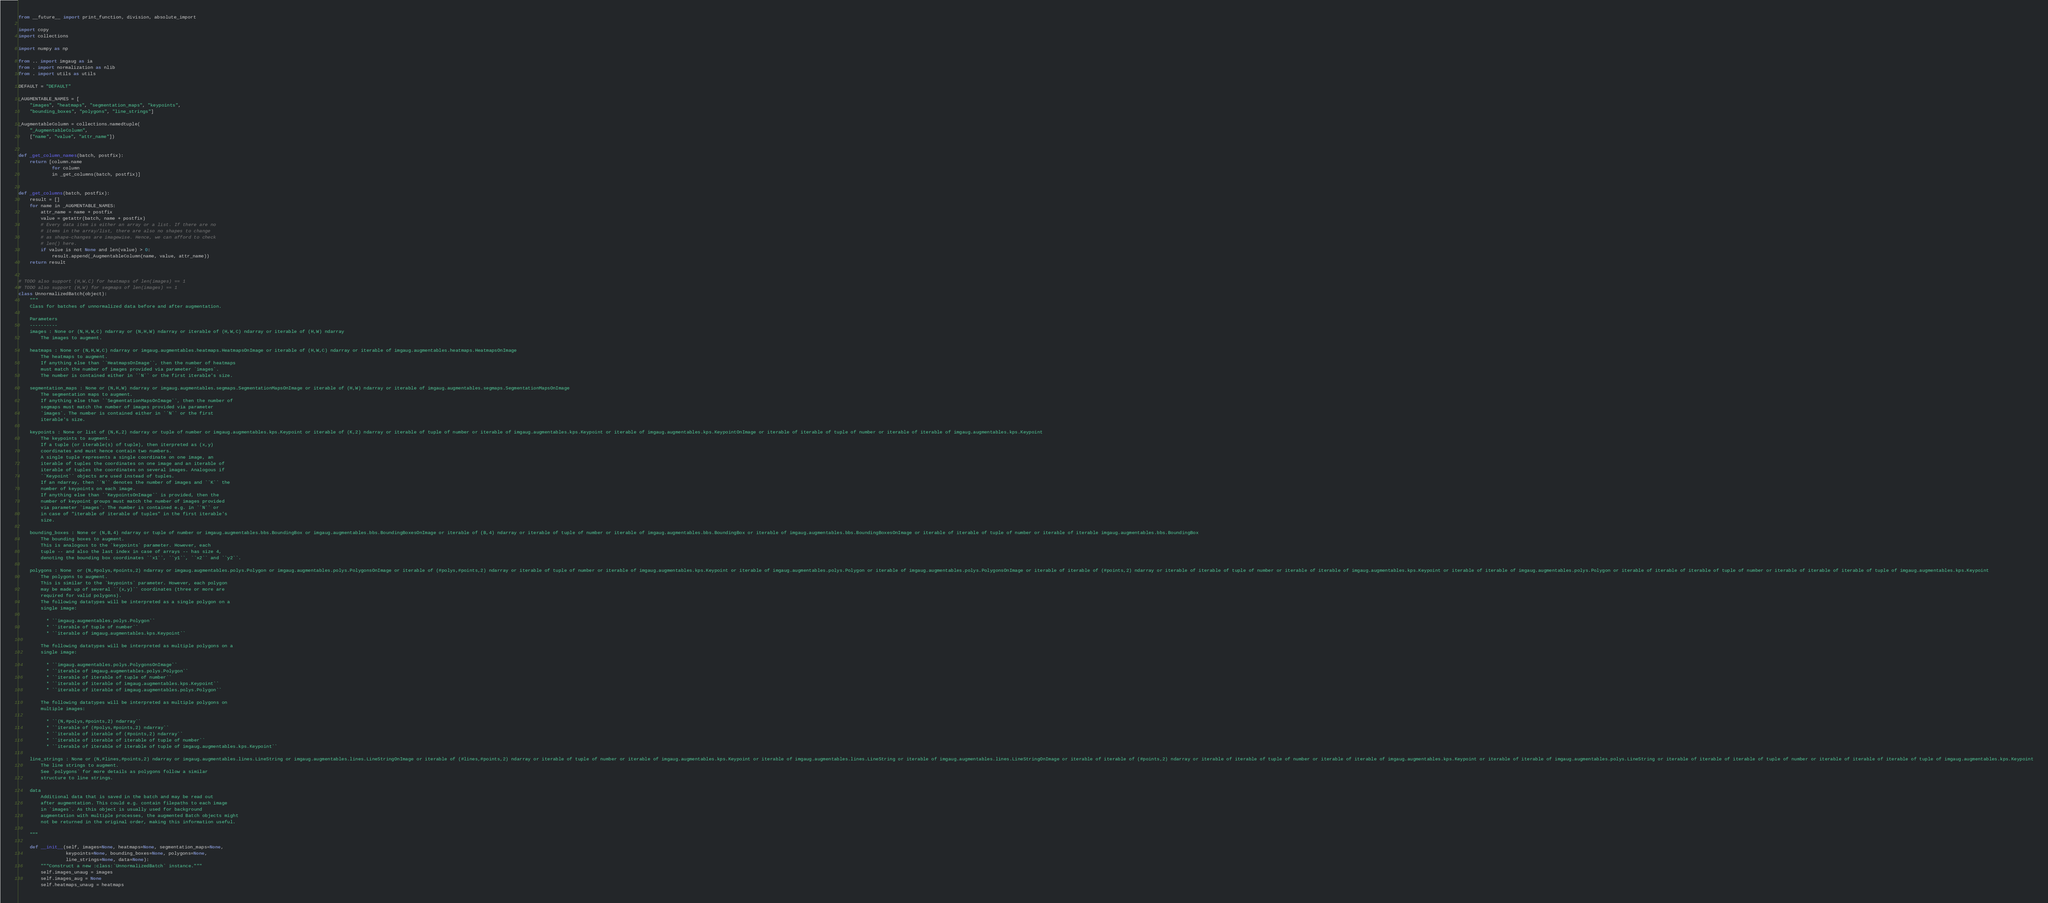Convert code to text. <code><loc_0><loc_0><loc_500><loc_500><_Python_>from __future__ import print_function, division, absolute_import

import copy
import collections

import numpy as np

from .. import imgaug as ia
from . import normalization as nlib
from . import utils as utils

DEFAULT = "DEFAULT"

_AUGMENTABLE_NAMES = [
    "images", "heatmaps", "segmentation_maps", "keypoints",
    "bounding_boxes", "polygons", "line_strings"]

_AugmentableColumn = collections.namedtuple(
    "_AugmentableColumn",
    ["name", "value", "attr_name"])


def _get_column_names(batch, postfix):
    return [column.name
            for column
            in _get_columns(batch, postfix)]


def _get_columns(batch, postfix):
    result = []
    for name in _AUGMENTABLE_NAMES:
        attr_name = name + postfix
        value = getattr(batch, name + postfix)
        # Every data item is either an array or a list. If there are no
        # items in the array/list, there are also no shapes to change
        # as shape-changes are imagewise. Hence, we can afford to check
        # len() here.
        if value is not None and len(value) > 0:
            result.append(_AugmentableColumn(name, value, attr_name))
    return result


# TODO also support (H,W,C) for heatmaps of len(images) == 1
# TODO also support (H,W) for segmaps of len(images) == 1
class UnnormalizedBatch(object):
    """
    Class for batches of unnormalized data before and after augmentation.

    Parameters
    ----------
    images : None or (N,H,W,C) ndarray or (N,H,W) ndarray or iterable of (H,W,C) ndarray or iterable of (H,W) ndarray
        The images to augment.

    heatmaps : None or (N,H,W,C) ndarray or imgaug.augmentables.heatmaps.HeatmapsOnImage or iterable of (H,W,C) ndarray or iterable of imgaug.augmentables.heatmaps.HeatmapsOnImage
        The heatmaps to augment.
        If anything else than ``HeatmapsOnImage``, then the number of heatmaps
        must match the number of images provided via parameter `images`.
        The number is contained either in ``N`` or the first iterable's size.

    segmentation_maps : None or (N,H,W) ndarray or imgaug.augmentables.segmaps.SegmentationMapsOnImage or iterable of (H,W) ndarray or iterable of imgaug.augmentables.segmaps.SegmentationMapsOnImage
        The segmentation maps to augment.
        If anything else than ``SegmentationMapsOnImage``, then the number of
        segmaps must match the number of images provided via parameter
        `images`. The number is contained either in ``N`` or the first
        iterable's size.

    keypoints : None or list of (N,K,2) ndarray or tuple of number or imgaug.augmentables.kps.Keypoint or iterable of (K,2) ndarray or iterable of tuple of number or iterable of imgaug.augmentables.kps.Keypoint or iterable of imgaug.augmentables.kps.KeypointOnImage or iterable of iterable of tuple of number or iterable of iterable of imgaug.augmentables.kps.Keypoint
        The keypoints to augment.
        If a tuple (or iterable(s) of tuple), then iterpreted as (x,y)
        coordinates and must hence contain two numbers.
        A single tuple represents a single coordinate on one image, an
        iterable of tuples the coordinates on one image and an iterable of
        iterable of tuples the coordinates on several images. Analogous if
        ``Keypoint`` objects are used instead of tuples.
        If an ndarray, then ``N`` denotes the number of images and ``K`` the
        number of keypoints on each image.
        If anything else than ``KeypointsOnImage`` is provided, then the
        number of keypoint groups must match the number of images provided
        via parameter `images`. The number is contained e.g. in ``N`` or
        in case of "iterable of iterable of tuples" in the first iterable's
        size.

    bounding_boxes : None or (N,B,4) ndarray or tuple of number or imgaug.augmentables.bbs.BoundingBox or imgaug.augmentables.bbs.BoundingBoxesOnImage or iterable of (B,4) ndarray or iterable of tuple of number or iterable of imgaug.augmentables.bbs.BoundingBox or iterable of imgaug.augmentables.bbs.BoundingBoxesOnImage or iterable of iterable of tuple of number or iterable of iterable imgaug.augmentables.bbs.BoundingBox
        The bounding boxes to augment.
        This is analogous to the `keypoints` parameter. However, each
        tuple -- and also the last index in case of arrays -- has size 4,
        denoting the bounding box coordinates ``x1``, ``y1``, ``x2`` and ``y2``.

    polygons : None  or (N,#polys,#points,2) ndarray or imgaug.augmentables.polys.Polygon or imgaug.augmentables.polys.PolygonsOnImage or iterable of (#polys,#points,2) ndarray or iterable of tuple of number or iterable of imgaug.augmentables.kps.Keypoint or iterable of imgaug.augmentables.polys.Polygon or iterable of imgaug.augmentables.polys.PolygonsOnImage or iterable of iterable of (#points,2) ndarray or iterable of iterable of tuple of number or iterable of iterable of imgaug.augmentables.kps.Keypoint or iterable of iterable of imgaug.augmentables.polys.Polygon or iterable of iterable of iterable of tuple of number or iterable of iterable of iterable of tuple of imgaug.augmentables.kps.Keypoint
        The polygons to augment.
        This is similar to the `keypoints` parameter. However, each polygon
        may be made up of several ``(x,y)`` coordinates (three or more are
        required for valid polygons).
        The following datatypes will be interpreted as a single polygon on a
        single image:

          * ``imgaug.augmentables.polys.Polygon``
          * ``iterable of tuple of number``
          * ``iterable of imgaug.augmentables.kps.Keypoint``

        The following datatypes will be interpreted as multiple polygons on a
        single image:

          * ``imgaug.augmentables.polys.PolygonsOnImage``
          * ``iterable of imgaug.augmentables.polys.Polygon``
          * ``iterable of iterable of tuple of number``
          * ``iterable of iterable of imgaug.augmentables.kps.Keypoint``
          * ``iterable of iterable of imgaug.augmentables.polys.Polygon``

        The following datatypes will be interpreted as multiple polygons on
        multiple images:

          * ``(N,#polys,#points,2) ndarray``
          * ``iterable of (#polys,#points,2) ndarray``
          * ``iterable of iterable of (#points,2) ndarray``
          * ``iterable of iterable of iterable of tuple of number``
          * ``iterable of iterable of iterable of tuple of imgaug.augmentables.kps.Keypoint``

    line_strings : None or (N,#lines,#points,2) ndarray or imgaug.augmentables.lines.LineString or imgaug.augmentables.lines.LineStringOnImage or iterable of (#lines,#points,2) ndarray or iterable of tuple of number or iterable of imgaug.augmentables.kps.Keypoint or iterable of imgaug.augmentables.lines.LineString or iterable of imgaug.augmentables.lines.LineStringOnImage or iterable of iterable of (#points,2) ndarray or iterable of iterable of tuple of number or iterable of iterable of imgaug.augmentables.kps.Keypoint or iterable of iterable of imgaug.augmentables.polys.LineString or iterable of iterable of iterable of tuple of number or iterable of iterable of iterable of tuple of imgaug.augmentables.kps.Keypoint
        The line strings to augment.
        See `polygons` for more details as polygons follow a similar
        structure to line strings.

    data
        Additional data that is saved in the batch and may be read out
        after augmentation. This could e.g. contain filepaths to each image
        in `images`. As this object is usually used for background
        augmentation with multiple processes, the augmented Batch objects might
        not be returned in the original order, making this information useful.

    """

    def __init__(self, images=None, heatmaps=None, segmentation_maps=None,
                 keypoints=None, bounding_boxes=None, polygons=None,
                 line_strings=None, data=None):
        """Construct a new :class:`UnnormalizedBatch` instance."""
        self.images_unaug = images
        self.images_aug = None
        self.heatmaps_unaug = heatmaps</code> 